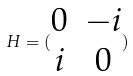<formula> <loc_0><loc_0><loc_500><loc_500>H = ( \begin{matrix} 0 & - i \\ i & 0 \end{matrix} )</formula> 